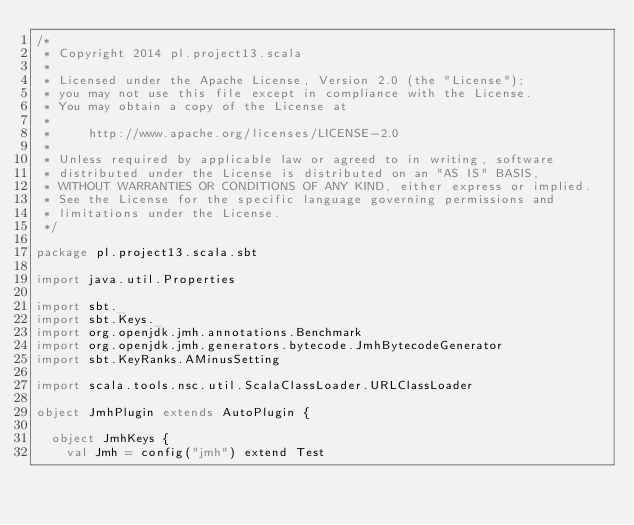<code> <loc_0><loc_0><loc_500><loc_500><_Scala_>/*
 * Copyright 2014 pl.project13.scala
 *
 * Licensed under the Apache License, Version 2.0 (the "License");
 * you may not use this file except in compliance with the License.
 * You may obtain a copy of the License at
 *
 *     http://www.apache.org/licenses/LICENSE-2.0
 *
 * Unless required by applicable law or agreed to in writing, software
 * distributed under the License is distributed on an "AS IS" BASIS,
 * WITHOUT WARRANTIES OR CONDITIONS OF ANY KIND, either express or implied.
 * See the License for the specific language governing permissions and
 * limitations under the License.
 */

package pl.project13.scala.sbt

import java.util.Properties

import sbt._
import sbt.Keys._
import org.openjdk.jmh.annotations.Benchmark
import org.openjdk.jmh.generators.bytecode.JmhBytecodeGenerator
import sbt.KeyRanks.AMinusSetting

import scala.tools.nsc.util.ScalaClassLoader.URLClassLoader

object JmhPlugin extends AutoPlugin {

  object JmhKeys {
    val Jmh = config("jmh") extend Test</code> 